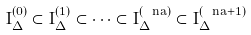<formula> <loc_0><loc_0><loc_500><loc_500>I _ { \Delta } ^ { ( 0 ) } \subset I _ { \Delta } ^ { ( 1 ) } \subset \dots \subset I _ { \Delta } ^ { ( \ n a ) } \subset I _ { \Delta } ^ { ( \ n a + 1 ) }</formula> 